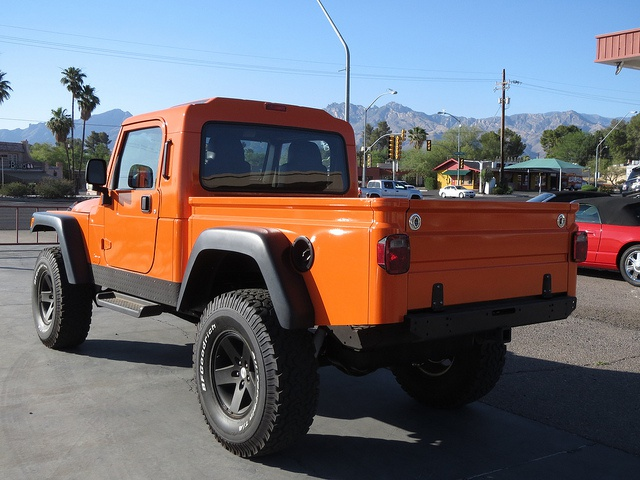Describe the objects in this image and their specific colors. I can see truck in lightblue, black, maroon, gray, and red tones, car in lightblue, black, red, gray, and salmon tones, car in lightblue, gray, black, and darkblue tones, car in lightblue, black, and gray tones, and car in lightblue, white, gray, darkgray, and black tones in this image. 